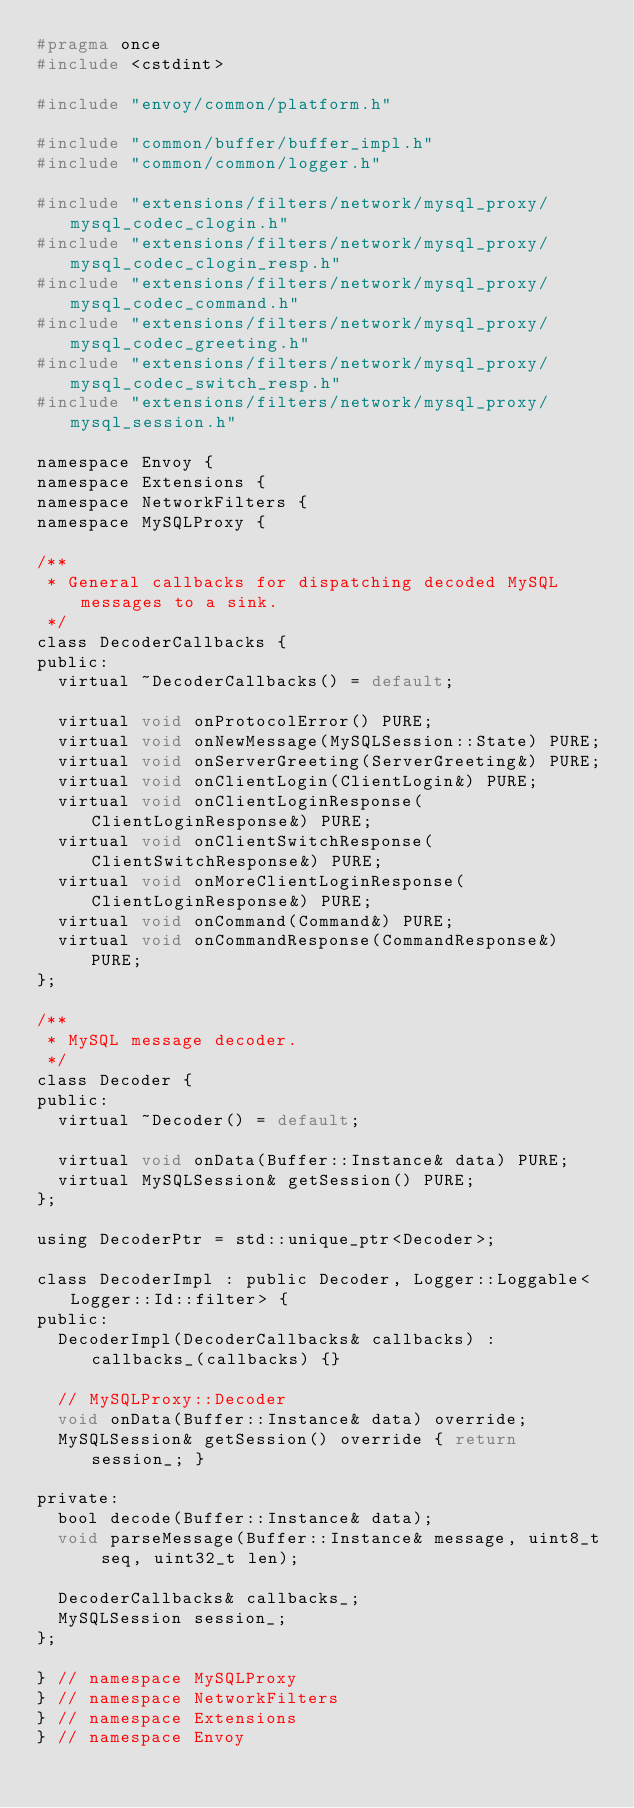Convert code to text. <code><loc_0><loc_0><loc_500><loc_500><_C_>#pragma once
#include <cstdint>

#include "envoy/common/platform.h"

#include "common/buffer/buffer_impl.h"
#include "common/common/logger.h"

#include "extensions/filters/network/mysql_proxy/mysql_codec_clogin.h"
#include "extensions/filters/network/mysql_proxy/mysql_codec_clogin_resp.h"
#include "extensions/filters/network/mysql_proxy/mysql_codec_command.h"
#include "extensions/filters/network/mysql_proxy/mysql_codec_greeting.h"
#include "extensions/filters/network/mysql_proxy/mysql_codec_switch_resp.h"
#include "extensions/filters/network/mysql_proxy/mysql_session.h"

namespace Envoy {
namespace Extensions {
namespace NetworkFilters {
namespace MySQLProxy {

/**
 * General callbacks for dispatching decoded MySQL messages to a sink.
 */
class DecoderCallbacks {
public:
  virtual ~DecoderCallbacks() = default;

  virtual void onProtocolError() PURE;
  virtual void onNewMessage(MySQLSession::State) PURE;
  virtual void onServerGreeting(ServerGreeting&) PURE;
  virtual void onClientLogin(ClientLogin&) PURE;
  virtual void onClientLoginResponse(ClientLoginResponse&) PURE;
  virtual void onClientSwitchResponse(ClientSwitchResponse&) PURE;
  virtual void onMoreClientLoginResponse(ClientLoginResponse&) PURE;
  virtual void onCommand(Command&) PURE;
  virtual void onCommandResponse(CommandResponse&) PURE;
};

/**
 * MySQL message decoder.
 */
class Decoder {
public:
  virtual ~Decoder() = default;

  virtual void onData(Buffer::Instance& data) PURE;
  virtual MySQLSession& getSession() PURE;
};

using DecoderPtr = std::unique_ptr<Decoder>;

class DecoderImpl : public Decoder, Logger::Loggable<Logger::Id::filter> {
public:
  DecoderImpl(DecoderCallbacks& callbacks) : callbacks_(callbacks) {}

  // MySQLProxy::Decoder
  void onData(Buffer::Instance& data) override;
  MySQLSession& getSession() override { return session_; }

private:
  bool decode(Buffer::Instance& data);
  void parseMessage(Buffer::Instance& message, uint8_t seq, uint32_t len);

  DecoderCallbacks& callbacks_;
  MySQLSession session_;
};

} // namespace MySQLProxy
} // namespace NetworkFilters
} // namespace Extensions
} // namespace Envoy
</code> 